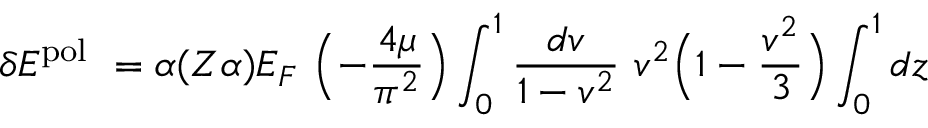Convert formula to latex. <formula><loc_0><loc_0><loc_500><loc_500>\delta E ^ { p o l } = \alpha ( Z \alpha ) E _ { F } \left ( - \frac { 4 \mu } { \pi ^ { 2 } } \right ) \int _ { 0 } ^ { 1 } \frac { d v } { 1 - v ^ { 2 } } v ^ { 2 } \left ( 1 - \frac { v ^ { 2 } } { 3 } \right ) \int _ { 0 } ^ { 1 } { d z }</formula> 